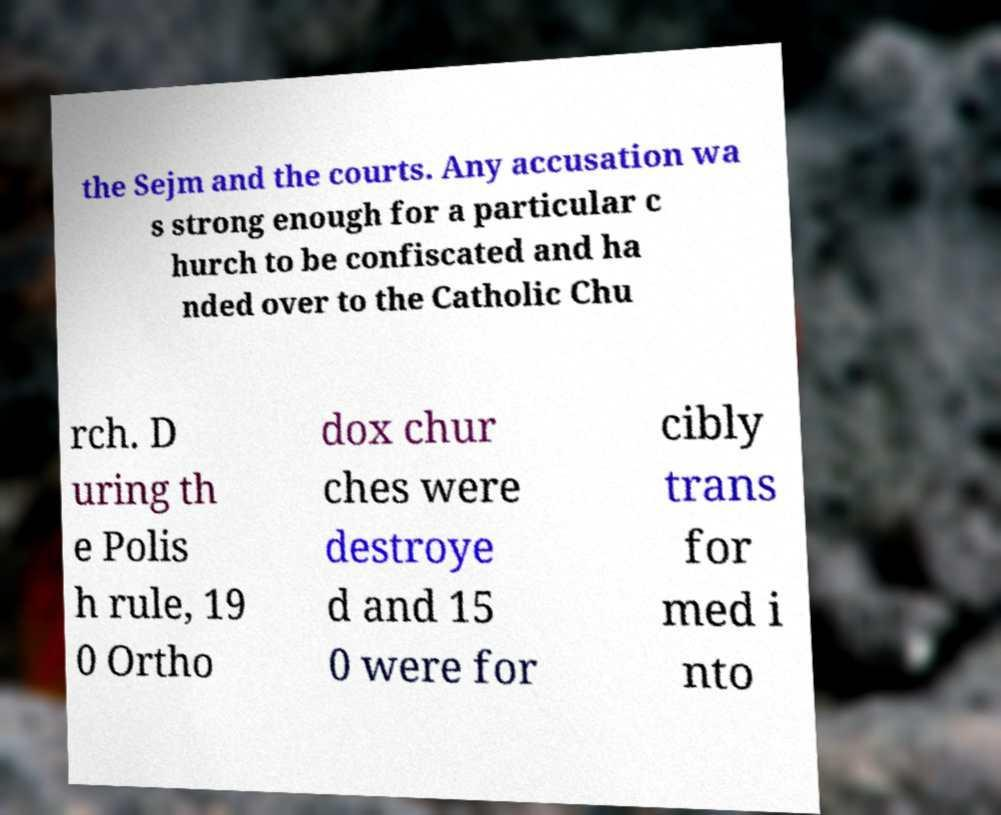Could you extract and type out the text from this image? the Sejm and the courts. Any accusation wa s strong enough for a particular c hurch to be confiscated and ha nded over to the Catholic Chu rch. D uring th e Polis h rule, 19 0 Ortho dox chur ches were destroye d and 15 0 were for cibly trans for med i nto 